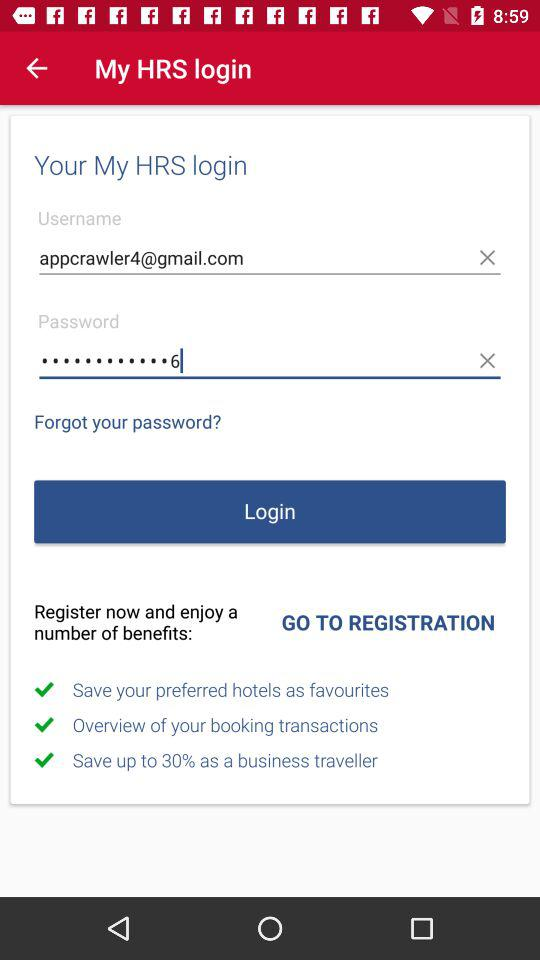How much money can we save on business travel? You can save up to 30%. 